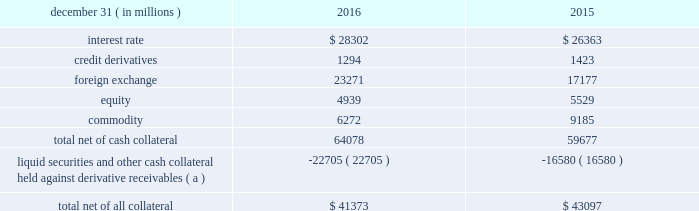Management 2019s discussion and analysis 102 jpmorgan chase & co./2016 annual report derivative contracts in the normal course of business , the firm uses derivative instruments predominantly for market-making activities .
Derivatives enable customers to manage exposures to fluctuations in interest rates , currencies and other markets .
The firm also uses derivative instruments to manage its own credit and other market risk exposure .
The nature of the counterparty and the settlement mechanism of the derivative affect the credit risk to which the firm is exposed .
For otc derivatives the firm is exposed to the credit risk of the derivative counterparty .
For exchange- traded derivatives ( 201cetd 201d ) , such as futures and options and 201ccleared 201d over-the-counter ( 201cotc-cleared 201d ) derivatives , the firm is generally exposed to the credit risk of the relevant ccp .
Where possible , the firm seeks to mitigate its credit risk exposures arising from derivative transactions through the use of legally enforceable master netting arrangements and collateral agreements .
For further discussion of derivative contracts , counterparties and settlement types , see note 6 .
The table summarizes the net derivative receivables for the periods presented .
Derivative receivables .
( a ) includes collateral related to derivative instruments where an appropriate legal opinion has not been either sought or obtained .
Derivative receivables reported on the consolidated balance sheets were $ 64.1 billion and $ 59.7 billion at december 31 , 2016 and 2015 , respectively .
These amounts represent the fair value of the derivative contracts after giving effect to legally enforceable master netting agreements and cash collateral held by the firm .
However , in management 2019s view , the appropriate measure of current credit risk should also take into consideration additional liquid securities ( primarily u.s .
Government and agency securities and other group of seven nations ( 201cg7 201d ) government bonds ) and other cash collateral held by the firm aggregating $ 22.7 billion and $ 16.6 billion at december 31 , 2016 and 2015 , respectively , that may be used as security when the fair value of the client 2019s exposure is in the firm 2019s favor .
The change in derivative receivables was predominantly related to client-driven market-making activities in cib .
The increase in derivative receivables reflected the impact of market movements , which increased foreign exchange receivables , partially offset by reduced commodity derivative receivables .
In addition to the collateral described in the preceding paragraph , the firm also holds additional collateral ( primarily cash , g7 government securities , other liquid government-agency and guaranteed securities , and corporate debt and equity securities ) delivered by clients at the initiation of transactions , as well as collateral related to contracts that have a non-daily call frequency and collateral that the firm has agreed to return but has not yet settled as of the reporting date .
Although this collateral does not reduce the balances and is not included in the table above , it is available as security against potential exposure that could arise should the fair value of the client 2019s derivative transactions move in the firm 2019s favor .
The derivative receivables fair value , net of all collateral , also does not include other credit enhancements , such as letters of credit .
For additional information on the firm 2019s use of collateral agreements , see note 6 .
While useful as a current view of credit exposure , the net fair value of the derivative receivables does not capture the potential future variability of that credit exposure .
To capture the potential future variability of credit exposure , the firm calculates , on a client-by-client basis , three measures of potential derivatives-related credit loss : peak , derivative risk equivalent ( 201cdre 201d ) , and average exposure ( 201cavg 201d ) .
These measures all incorporate netting and collateral benefits , where applicable .
Peak represents a conservative measure of potential exposure to a counterparty calculated in a manner that is broadly equivalent to a 97.5% ( 97.5 % ) confidence level over the life of the transaction .
Peak is the primary measure used by the firm for setting of credit limits for derivative transactions , senior management reporting and derivatives exposure management .
Dre exposure is a measure that expresses the risk of derivative exposure on a basis intended to be equivalent to the risk of loan exposures .
Dre is a less extreme measure of potential credit loss than peak and is used for aggregating derivative credit risk exposures with loans and other credit risk .
Finally , avg is a measure of the expected fair value of the firm 2019s derivative receivables at future time periods , including the benefit of collateral .
Avg exposure over the total life of the derivative contract is used as the primary metric for pricing purposes and is used to calculate credit capital and the cva , as further described below .
The three year avg exposure was $ 31.1 billion and $ 32.4 billion at december 31 , 2016 and 2015 , respectively , compared with derivative receivables , net of all collateral , of $ 41.4 billion and $ 43.1 billion at december 31 , 2016 and 2015 , respectively .
The fair value of the firm 2019s derivative receivables incorporates an adjustment , the cva , to reflect the credit quality of counterparties .
The cva is based on the firm 2019s avg to a counterparty and the counterparty 2019s credit spread in the credit derivatives market .
The primary components of changes in cva are credit spreads , new deal activity or unwinds , and changes in the underlying market environment .
The firm believes that active risk management is essential to controlling the dynamic credit .
What was the ratio of the avg exposure compared with derivative receivables , net of all collateral in 2016? 
Computations: (31.1 / 41.4)
Answer: 0.75121. 